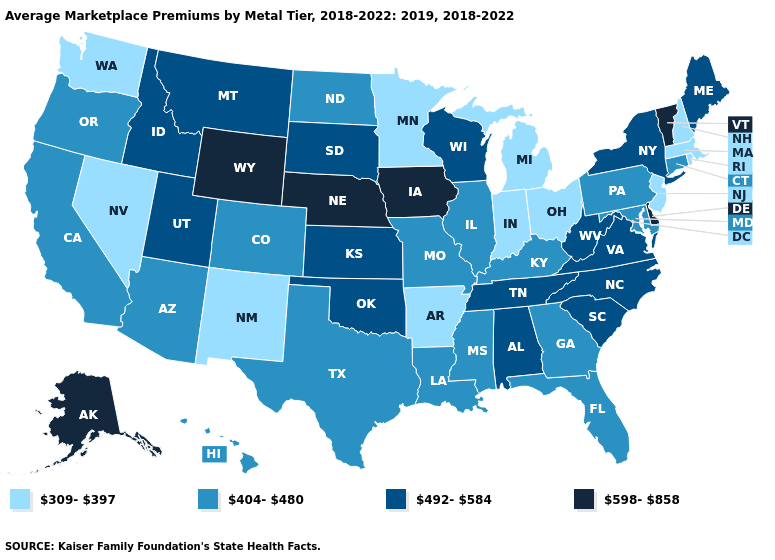Among the states that border New York , which have the highest value?
Keep it brief. Vermont. Which states have the highest value in the USA?
Answer briefly. Alaska, Delaware, Iowa, Nebraska, Vermont, Wyoming. Does Mississippi have a higher value than Virginia?
Concise answer only. No. Name the states that have a value in the range 404-480?
Be succinct. Arizona, California, Colorado, Connecticut, Florida, Georgia, Hawaii, Illinois, Kentucky, Louisiana, Maryland, Mississippi, Missouri, North Dakota, Oregon, Pennsylvania, Texas. Does Kansas have the highest value in the MidWest?
Concise answer only. No. What is the value of Louisiana?
Give a very brief answer. 404-480. Name the states that have a value in the range 309-397?
Give a very brief answer. Arkansas, Indiana, Massachusetts, Michigan, Minnesota, Nevada, New Hampshire, New Jersey, New Mexico, Ohio, Rhode Island, Washington. What is the value of New Mexico?
Concise answer only. 309-397. What is the value of Virginia?
Be succinct. 492-584. Which states have the lowest value in the Northeast?
Write a very short answer. Massachusetts, New Hampshire, New Jersey, Rhode Island. Name the states that have a value in the range 404-480?
Keep it brief. Arizona, California, Colorado, Connecticut, Florida, Georgia, Hawaii, Illinois, Kentucky, Louisiana, Maryland, Mississippi, Missouri, North Dakota, Oregon, Pennsylvania, Texas. Does the first symbol in the legend represent the smallest category?
Short answer required. Yes. What is the highest value in the USA?
Short answer required. 598-858. Which states hav the highest value in the Northeast?
Give a very brief answer. Vermont. Name the states that have a value in the range 598-858?
Be succinct. Alaska, Delaware, Iowa, Nebraska, Vermont, Wyoming. 